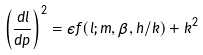<formula> <loc_0><loc_0><loc_500><loc_500>\left ( \frac { d l } { d p } \right ) ^ { 2 } = \epsilon f ( l ; m , \beta , h / k ) + k ^ { 2 }</formula> 